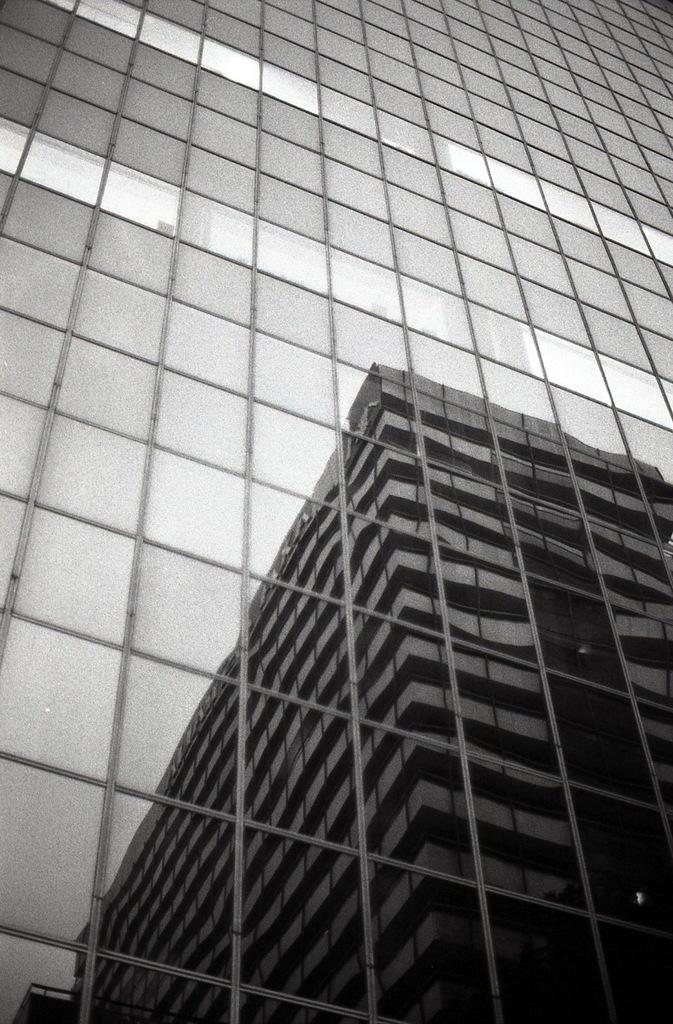What is the main subject of the image? The main subject of the image is a reflection of a building. Can you describe the reflection in more detail? The reflection appears to be clear and shows the building's structure and details. What type of reward can be seen hanging from the trees in the image? There are no trees or rewards present in the image; it only features a reflection of a building. 